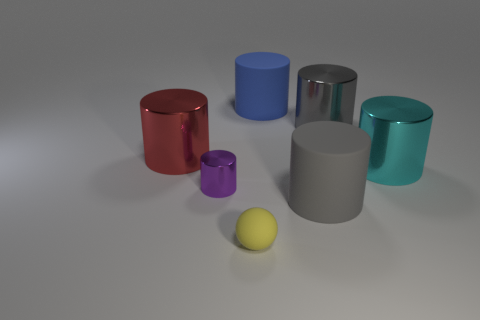Subtract all red shiny cylinders. How many cylinders are left? 5 Subtract all cyan cylinders. How many cylinders are left? 5 Subtract 2 cylinders. How many cylinders are left? 4 Subtract all brown cylinders. Subtract all red balls. How many cylinders are left? 6 Add 3 tiny purple balls. How many objects exist? 10 Subtract all spheres. How many objects are left? 6 Subtract 0 blue balls. How many objects are left? 7 Subtract all red shiny cylinders. Subtract all small purple objects. How many objects are left? 5 Add 7 big blue rubber cylinders. How many big blue rubber cylinders are left? 8 Add 2 rubber things. How many rubber things exist? 5 